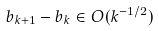Convert formula to latex. <formula><loc_0><loc_0><loc_500><loc_500>b _ { k + 1 } - b _ { k } \in O ( k ^ { - 1 / 2 } )</formula> 